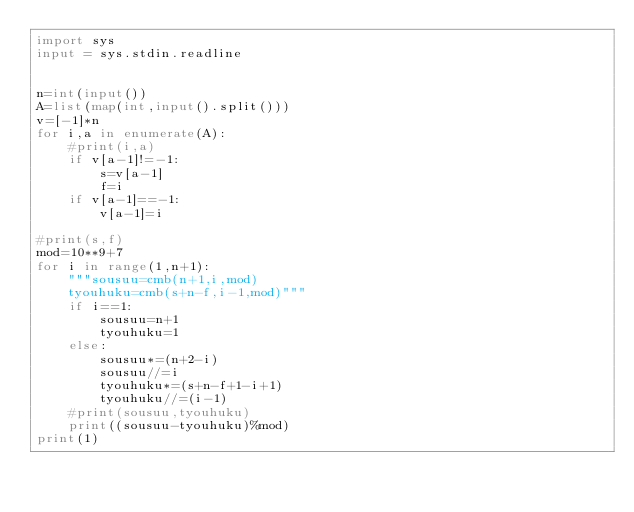<code> <loc_0><loc_0><loc_500><loc_500><_Python_>import sys
input = sys.stdin.readline


n=int(input())
A=list(map(int,input().split()))
v=[-1]*n
for i,a in enumerate(A):
    #print(i,a)
    if v[a-1]!=-1:
        s=v[a-1]
        f=i
    if v[a-1]==-1:
        v[a-1]=i

#print(s,f)
mod=10**9+7
for i in range(1,n+1):
    """sousuu=cmb(n+1,i,mod)
    tyouhuku=cmb(s+n-f,i-1,mod)"""
    if i==1:
        sousuu=n+1
        tyouhuku=1
    else:
        sousuu*=(n+2-i)
        sousuu//=i
        tyouhuku*=(s+n-f+1-i+1)
        tyouhuku//=(i-1)
    #print(sousuu,tyouhuku)
    print((sousuu-tyouhuku)%mod)
print(1)
</code> 